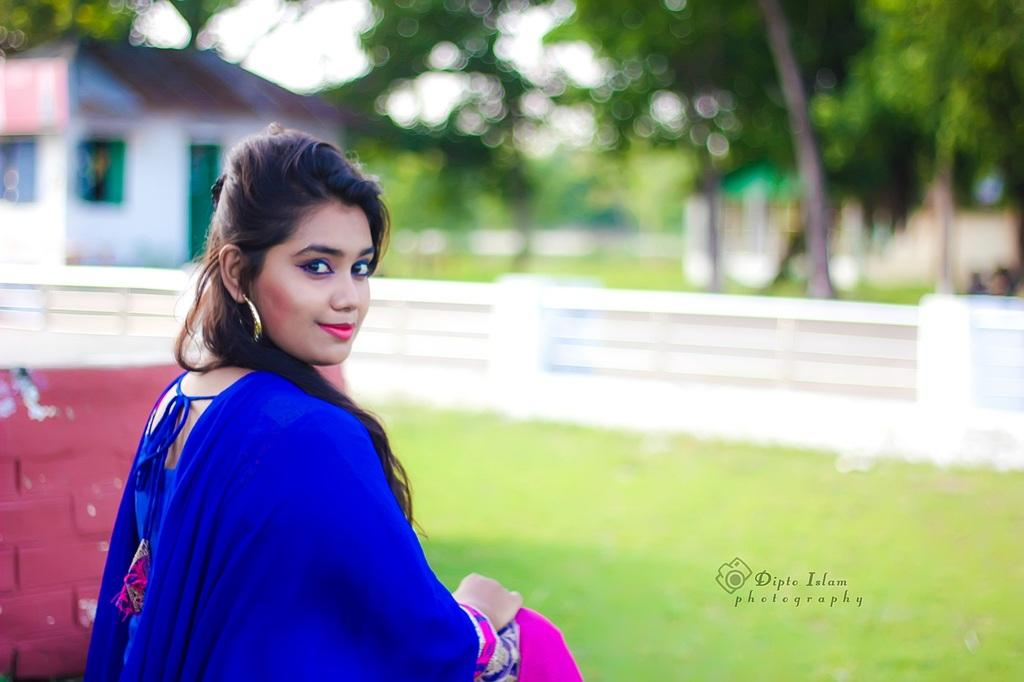Who is the main subject in the image? There is a girl in the image. What is the girl doing in the image? The girl is sitting on the grass. What can be seen in the background of the image? There is a building and trees in the background of the image. What grade is the girl in, based on the image? There is no information about the girl's grade in the image. What pen is the girl using to write in the image? There is no pen or writing activity visible in the image. 